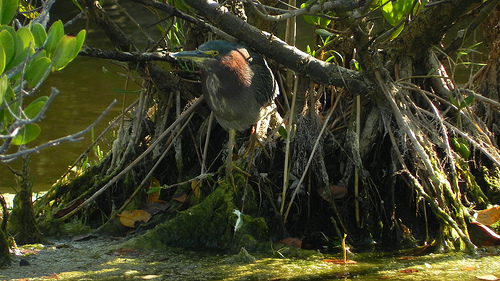<image>
Can you confirm if the bird is on the tree branch? No. The bird is not positioned on the tree branch. They may be near each other, but the bird is not supported by or resting on top of the tree branch. 